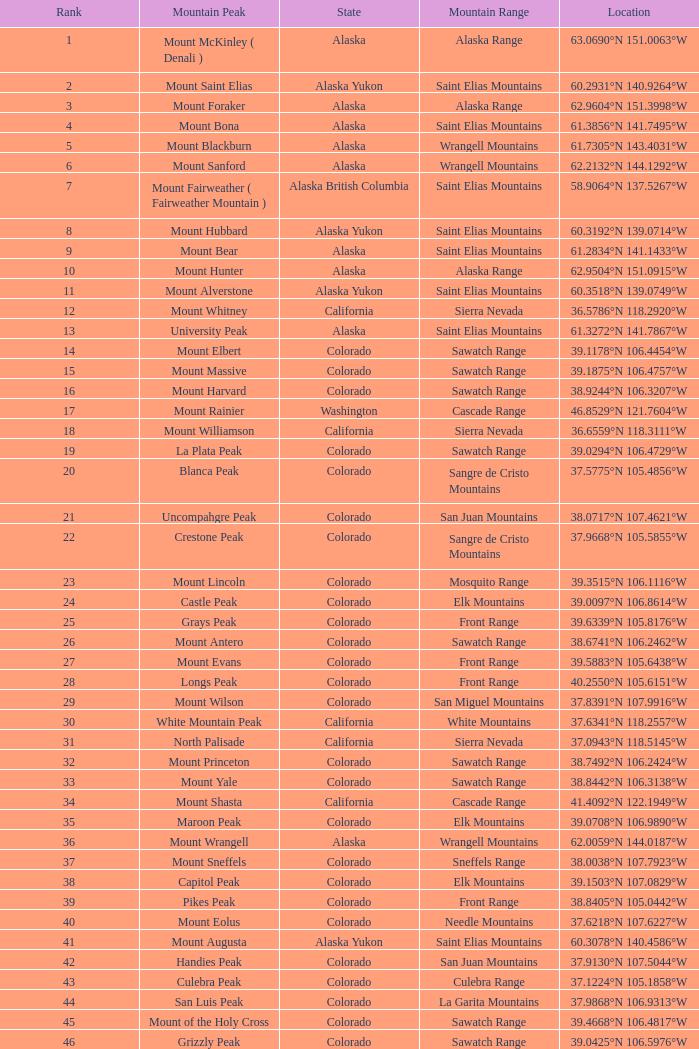What is the mountain range when the mountain peak is mauna kea? Island of Hawai ʻ i. 